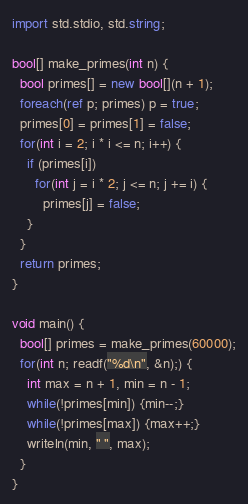Convert code to text. <code><loc_0><loc_0><loc_500><loc_500><_D_>
import std.stdio, std.string;

bool[] make_primes(int n) {
  bool primes[] = new bool[](n + 1);
  foreach(ref p; primes) p = true;
  primes[0] = primes[1] = false;
  for(int i = 2; i * i <= n; i++) {
    if (primes[i])
      for(int j = i * 2; j <= n; j += i) {
        primes[j] = false;
    }
  }
  return primes;
}

void main() {
  bool[] primes = make_primes(60000);
  for(int n; readf("%d\n", &n);) {
    int max = n + 1, min = n - 1;
    while(!primes[min]) {min--;}
    while(!primes[max]) {max++;}
    writeln(min, " ", max);
  }
}</code> 